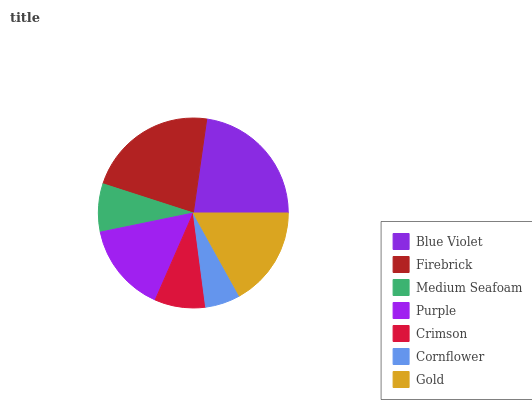Is Cornflower the minimum?
Answer yes or no. Yes. Is Blue Violet the maximum?
Answer yes or no. Yes. Is Firebrick the minimum?
Answer yes or no. No. Is Firebrick the maximum?
Answer yes or no. No. Is Blue Violet greater than Firebrick?
Answer yes or no. Yes. Is Firebrick less than Blue Violet?
Answer yes or no. Yes. Is Firebrick greater than Blue Violet?
Answer yes or no. No. Is Blue Violet less than Firebrick?
Answer yes or no. No. Is Purple the high median?
Answer yes or no. Yes. Is Purple the low median?
Answer yes or no. Yes. Is Firebrick the high median?
Answer yes or no. No. Is Firebrick the low median?
Answer yes or no. No. 